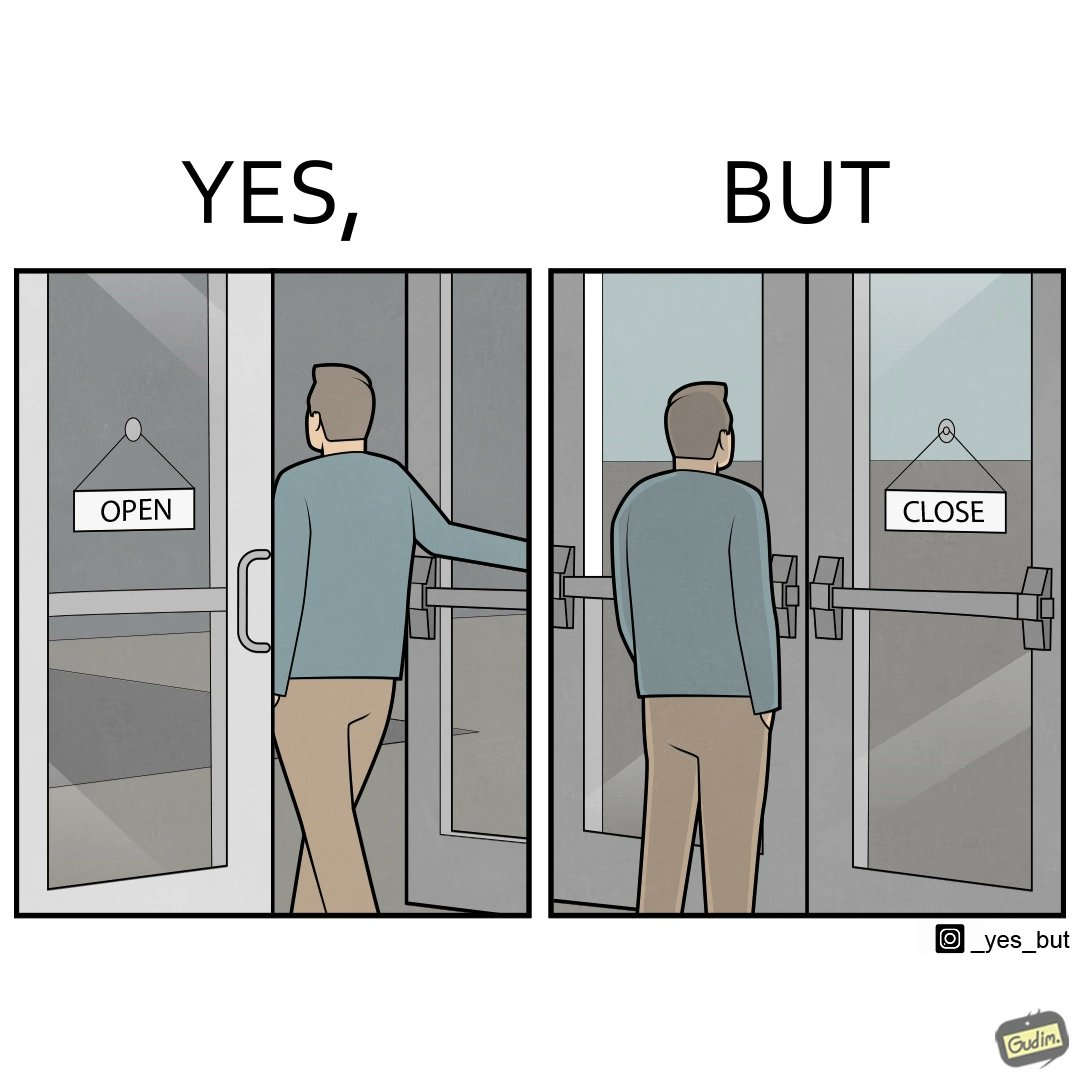Describe the content of this image. The image is funny because a person opens a door with the sign 'OPEN', meaning the place is open. However, once the person enters the building and looks back, the other side of the sign reads 'CLOSE', which ideally should not be the case, as the place is actually open. 